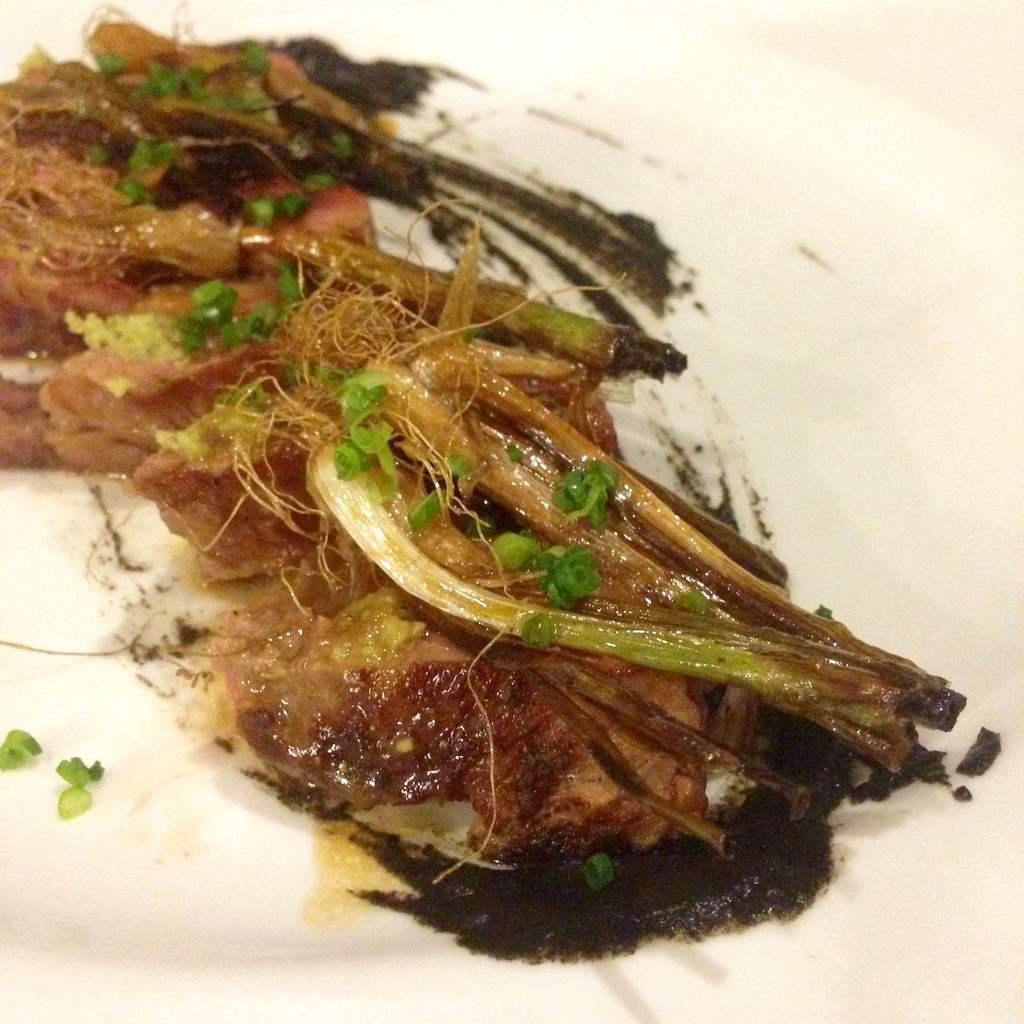Can you describe this image briefly? In the image there is some cooked food item served on a plate. 